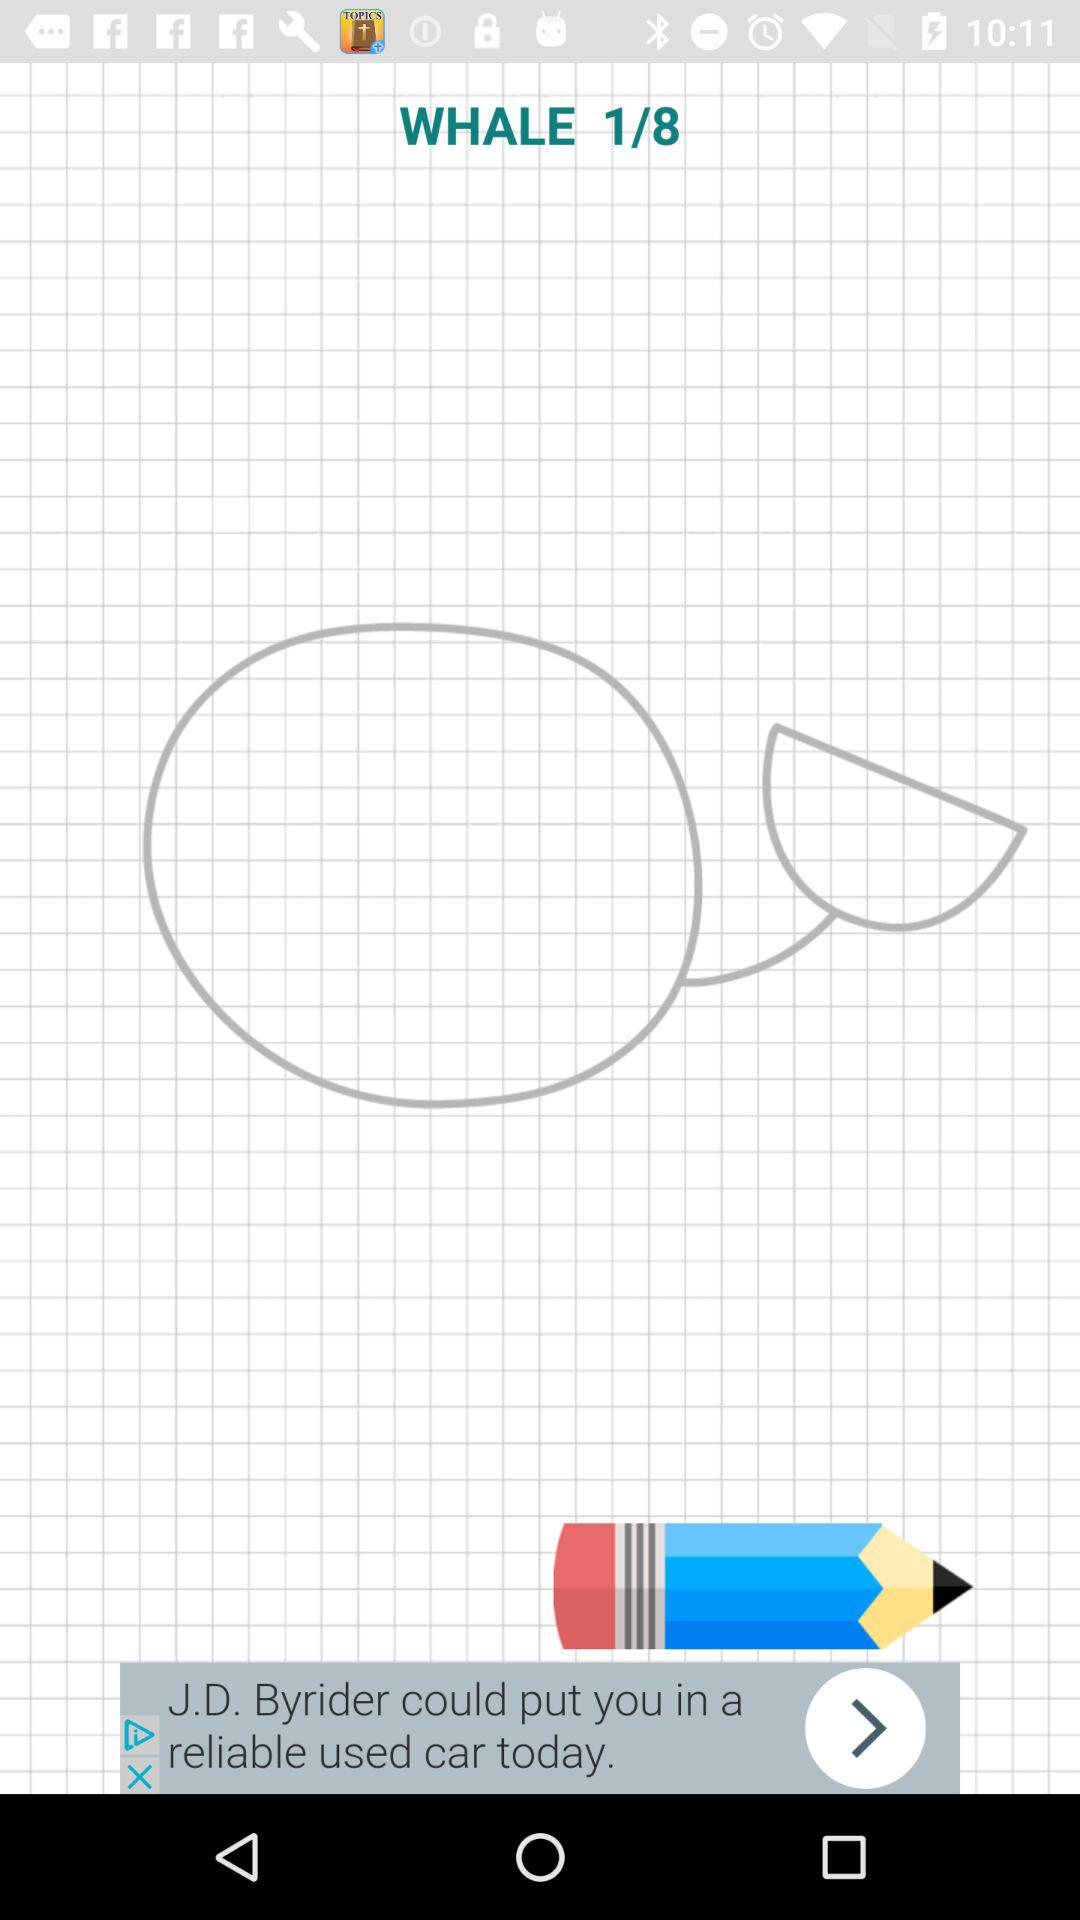What is the title of the image? The title of the image is Whale. 